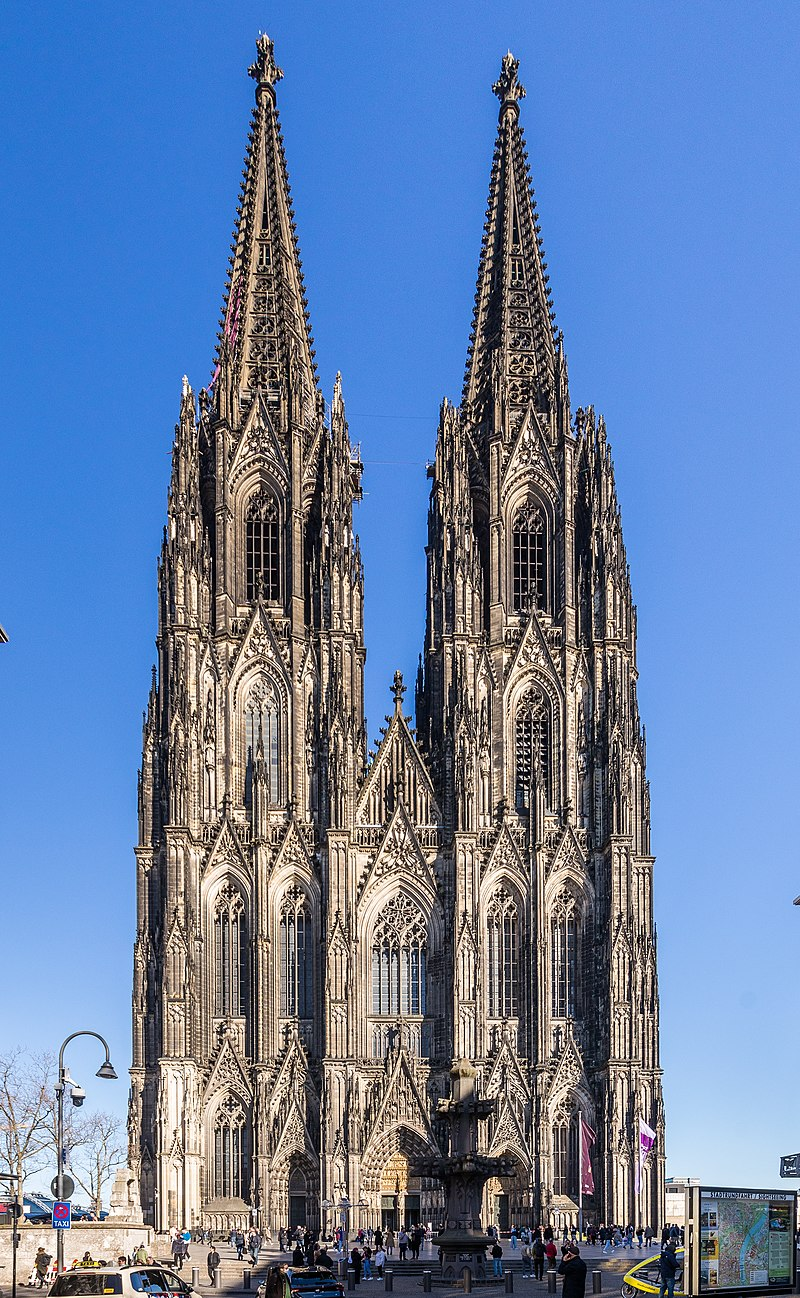What details can you provide about the history and construction of the Cologne Cathedral? The Cologne Cathedral, or Kölner Dom, began its construction in 1248 but was not completed until 1880, taking over 600 years due to various interruptions. It is known for its ambitious Gothic architecture, designed to house the relics of the Three Kings. Despite partial damages during World War II, the cathedral has been meticulously restored. It's renowned for holding the largest facade of any church in the world and for its two spires, which are among the tallest structures built in the Gothic era. 